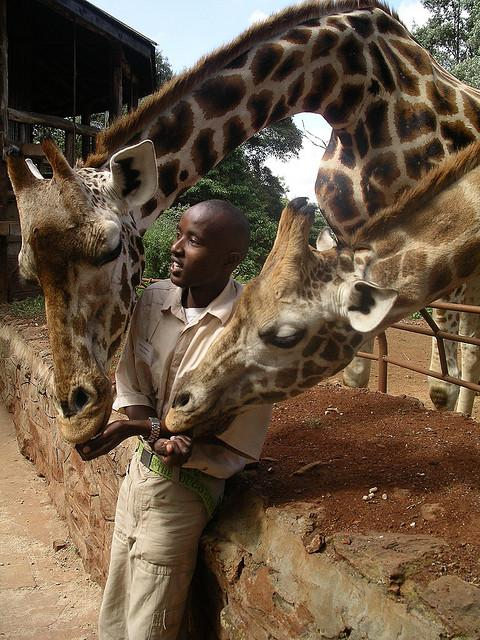What is the man near the giraffes job? Please explain your reasoning. zookeeper. The man is a zookeeper. 